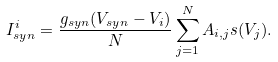<formula> <loc_0><loc_0><loc_500><loc_500>I _ { s y n } ^ { i } = \frac { g _ { s y n } ( V _ { s y n } - V _ { i } ) } { N } \sum _ { j = 1 } ^ { N } A _ { i , j } s ( V _ { j } ) .</formula> 